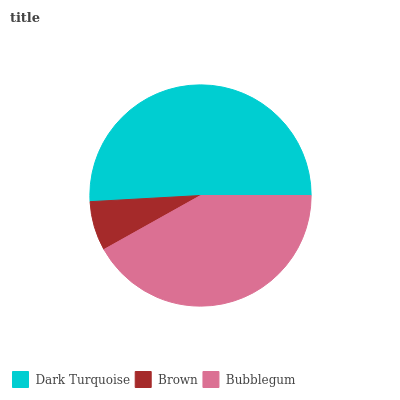Is Brown the minimum?
Answer yes or no. Yes. Is Dark Turquoise the maximum?
Answer yes or no. Yes. Is Bubblegum the minimum?
Answer yes or no. No. Is Bubblegum the maximum?
Answer yes or no. No. Is Bubblegum greater than Brown?
Answer yes or no. Yes. Is Brown less than Bubblegum?
Answer yes or no. Yes. Is Brown greater than Bubblegum?
Answer yes or no. No. Is Bubblegum less than Brown?
Answer yes or no. No. Is Bubblegum the high median?
Answer yes or no. Yes. Is Bubblegum the low median?
Answer yes or no. Yes. Is Dark Turquoise the high median?
Answer yes or no. No. Is Brown the low median?
Answer yes or no. No. 